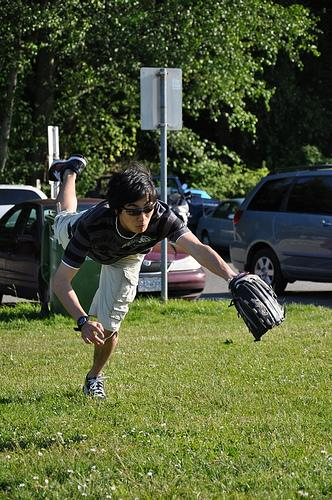What handedness does this person have?

Choices:
A) left
B) right
C) none
D) ambidextrous right 